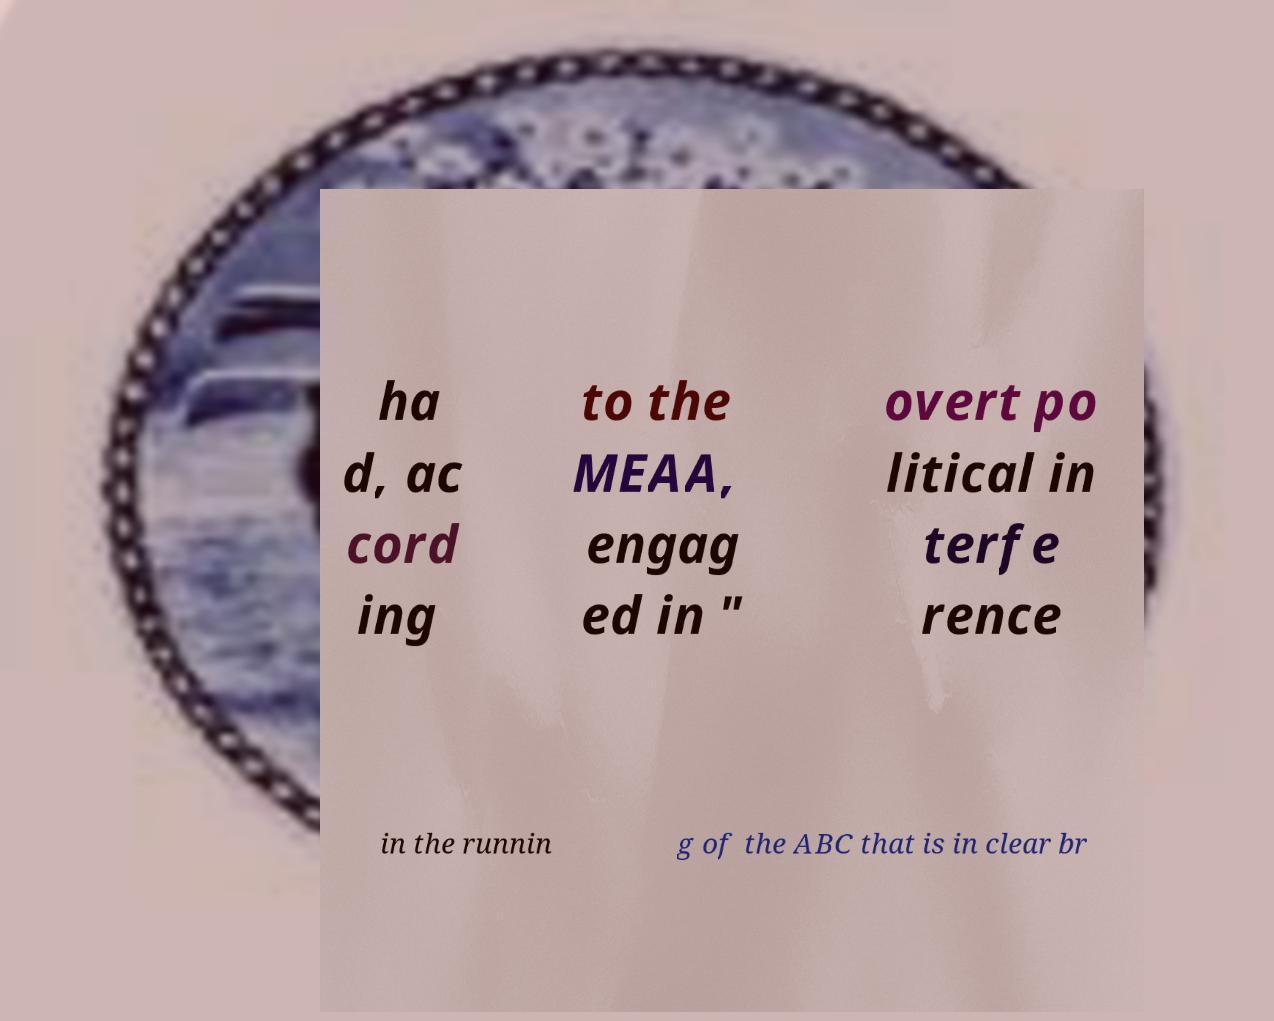Could you assist in decoding the text presented in this image and type it out clearly? ha d, ac cord ing to the MEAA, engag ed in " overt po litical in terfe rence in the runnin g of the ABC that is in clear br 